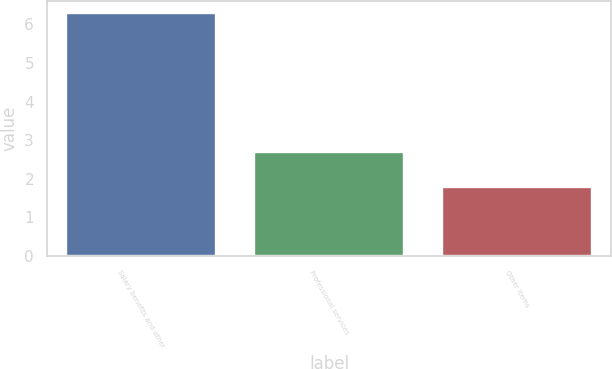Convert chart to OTSL. <chart><loc_0><loc_0><loc_500><loc_500><bar_chart><fcel>Salary benefits and other<fcel>Professional services<fcel>Other items<nl><fcel>6.3<fcel>2.7<fcel>1.8<nl></chart> 